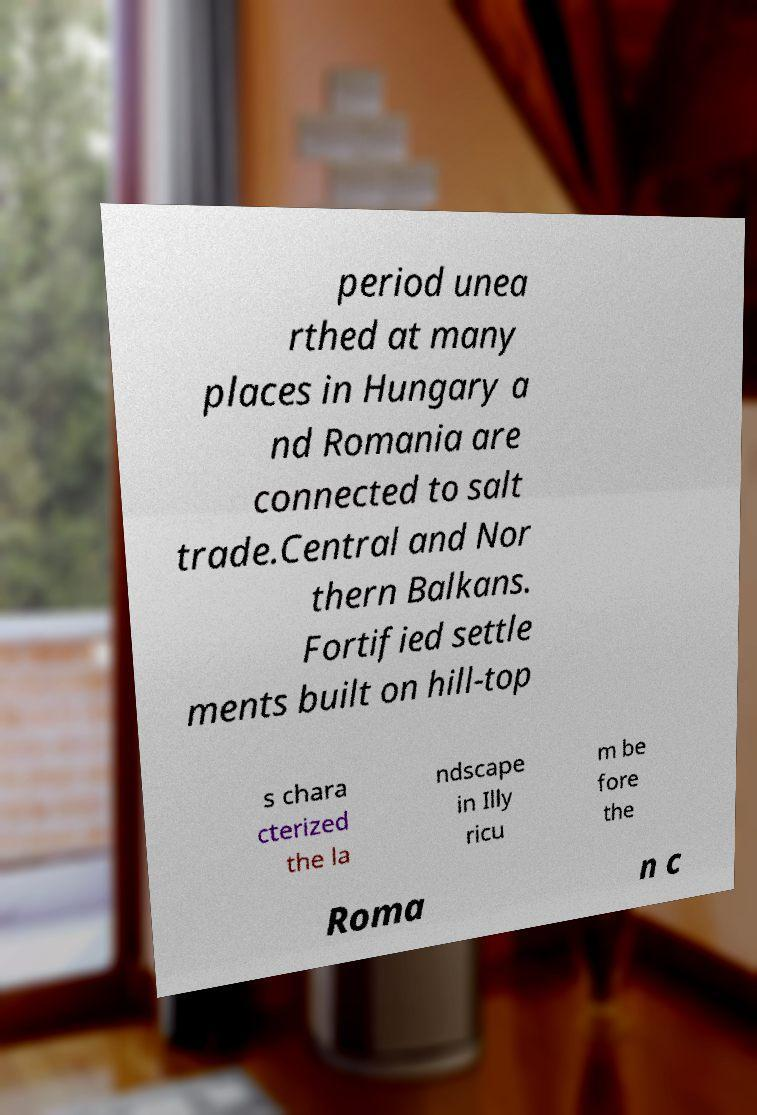For documentation purposes, I need the text within this image transcribed. Could you provide that? period unea rthed at many places in Hungary a nd Romania are connected to salt trade.Central and Nor thern Balkans. Fortified settle ments built on hill-top s chara cterized the la ndscape in Illy ricu m be fore the Roma n c 